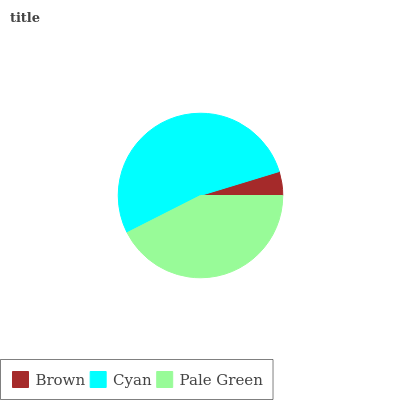Is Brown the minimum?
Answer yes or no. Yes. Is Cyan the maximum?
Answer yes or no. Yes. Is Pale Green the minimum?
Answer yes or no. No. Is Pale Green the maximum?
Answer yes or no. No. Is Cyan greater than Pale Green?
Answer yes or no. Yes. Is Pale Green less than Cyan?
Answer yes or no. Yes. Is Pale Green greater than Cyan?
Answer yes or no. No. Is Cyan less than Pale Green?
Answer yes or no. No. Is Pale Green the high median?
Answer yes or no. Yes. Is Pale Green the low median?
Answer yes or no. Yes. Is Cyan the high median?
Answer yes or no. No. Is Cyan the low median?
Answer yes or no. No. 